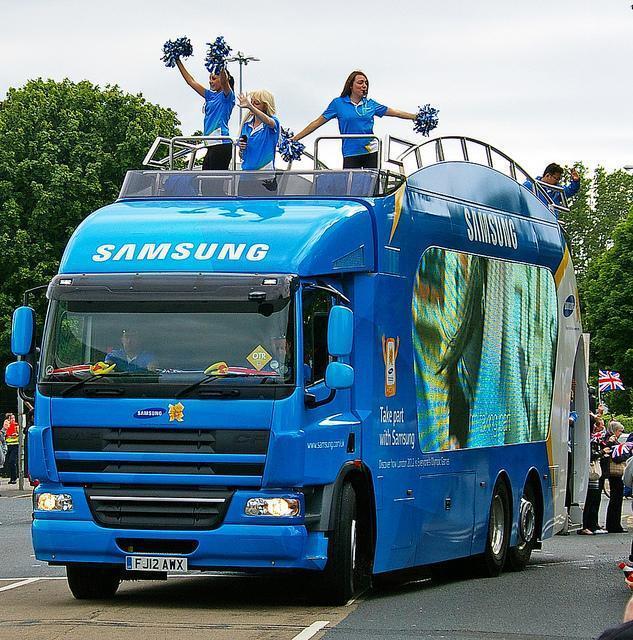How many people are there?
Give a very brief answer. 4. How many orange and white cats are in the image?
Give a very brief answer. 0. 